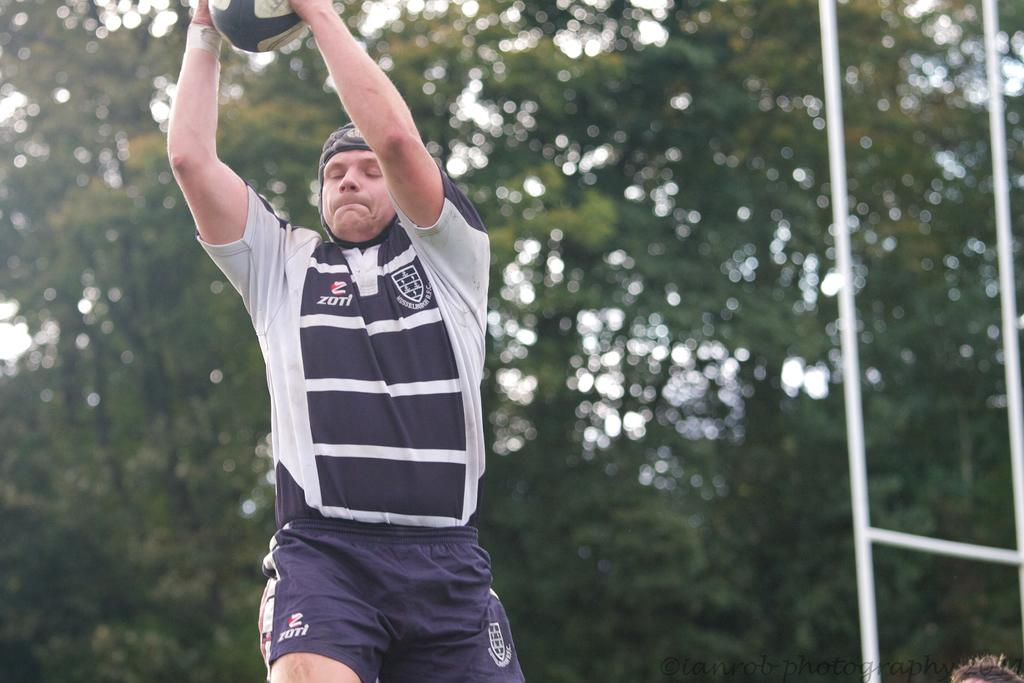<image>
Describe the image concisely. Man wearing a jersey that says "ZOTI" on the side. 